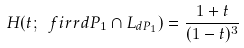<formula> <loc_0><loc_0><loc_500><loc_500>H ( t ; \ f i r r { d P _ { 1 } } \cap L _ { d P _ { 1 } } ) = \frac { 1 + t } { ( 1 - t ) ^ { 3 } }</formula> 